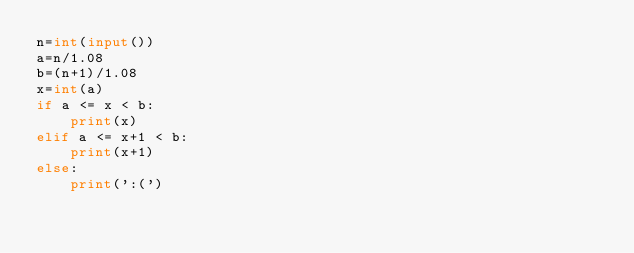<code> <loc_0><loc_0><loc_500><loc_500><_Python_>n=int(input())
a=n/1.08
b=(n+1)/1.08
x=int(a)
if a <= x < b:
    print(x)
elif a <= x+1 < b:
    print(x+1)
else:
    print(':(')</code> 